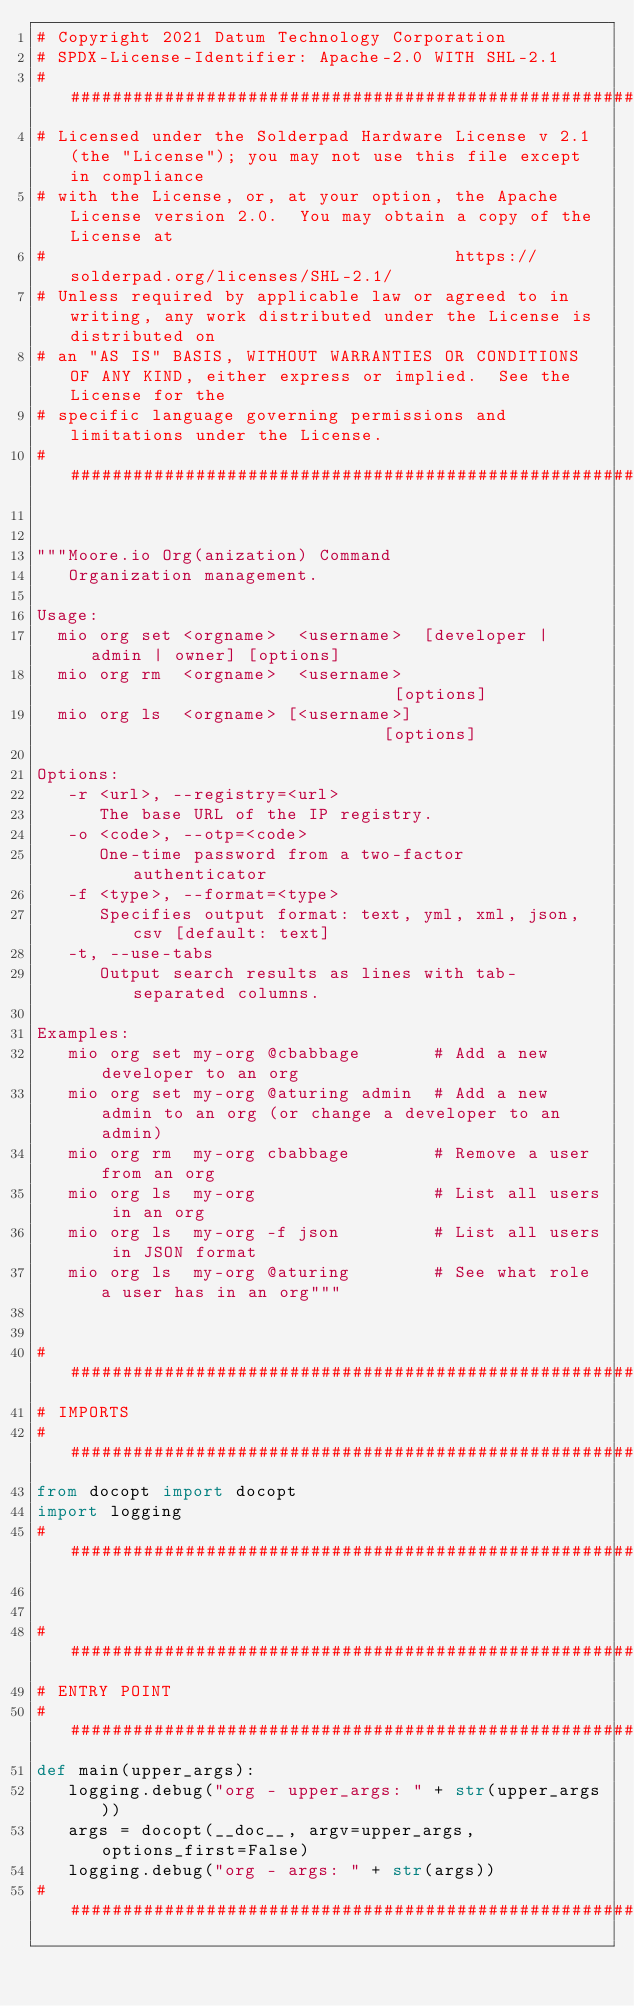Convert code to text. <code><loc_0><loc_0><loc_500><loc_500><_Python_># Copyright 2021 Datum Technology Corporation
# SPDX-License-Identifier: Apache-2.0 WITH SHL-2.1
########################################################################################################################
# Licensed under the Solderpad Hardware License v 2.1 (the "License"); you may not use this file except in compliance
# with the License, or, at your option, the Apache License version 2.0.  You may obtain a copy of the License at
#                                       https://solderpad.org/licenses/SHL-2.1/
# Unless required by applicable law or agreed to in writing, any work distributed under the License is distributed on
# an "AS IS" BASIS, WITHOUT WARRANTIES OR CONDITIONS OF ANY KIND, either express or implied.  See the License for the
# specific language governing permissions and limitations under the License.
########################################################################################################################


"""Moore.io Org(anization) Command
   Organization management.

Usage:
  mio org set <orgname>  <username>  [developer | admin | owner] [options]
  mio org rm  <orgname>  <username>                              [options]
  mio org ls  <orgname> [<username>]                             [options]

Options:
   -r <url>, --registry=<url>
      The base URL of the IP registry.
   -o <code>, --otp=<code>
      One-time password from a two-factor authenticator
   -f <type>, --format=<type>
      Specifies output format: text, yml, xml, json, csv [default: text]
   -t, --use-tabs
      Output search results as lines with tab-separated columns.

Examples:
   mio org set my-org @cbabbage       # Add a new developer to an org
   mio org set my-org @aturing admin  # Add a new admin to an org (or change a developer to an admin)
   mio org rm  my-org cbabbage        # Remove a user from an org
   mio org ls  my-org                 # List all users in an org
   mio org ls  my-org -f json         # List all users in JSON format
   mio org ls  my-org @aturing        # See what role a user has in an org"""


########################################################################################################################
# IMPORTS
########################################################################################################################
from docopt import docopt
import logging
########################################################################################################################


########################################################################################################################
# ENTRY POINT
########################################################################################################################
def main(upper_args):
   logging.debug("org - upper_args: " + str(upper_args))
   args = docopt(__doc__, argv=upper_args, options_first=False)
   logging.debug("org - args: " + str(args))
########################################################################################################################
</code> 